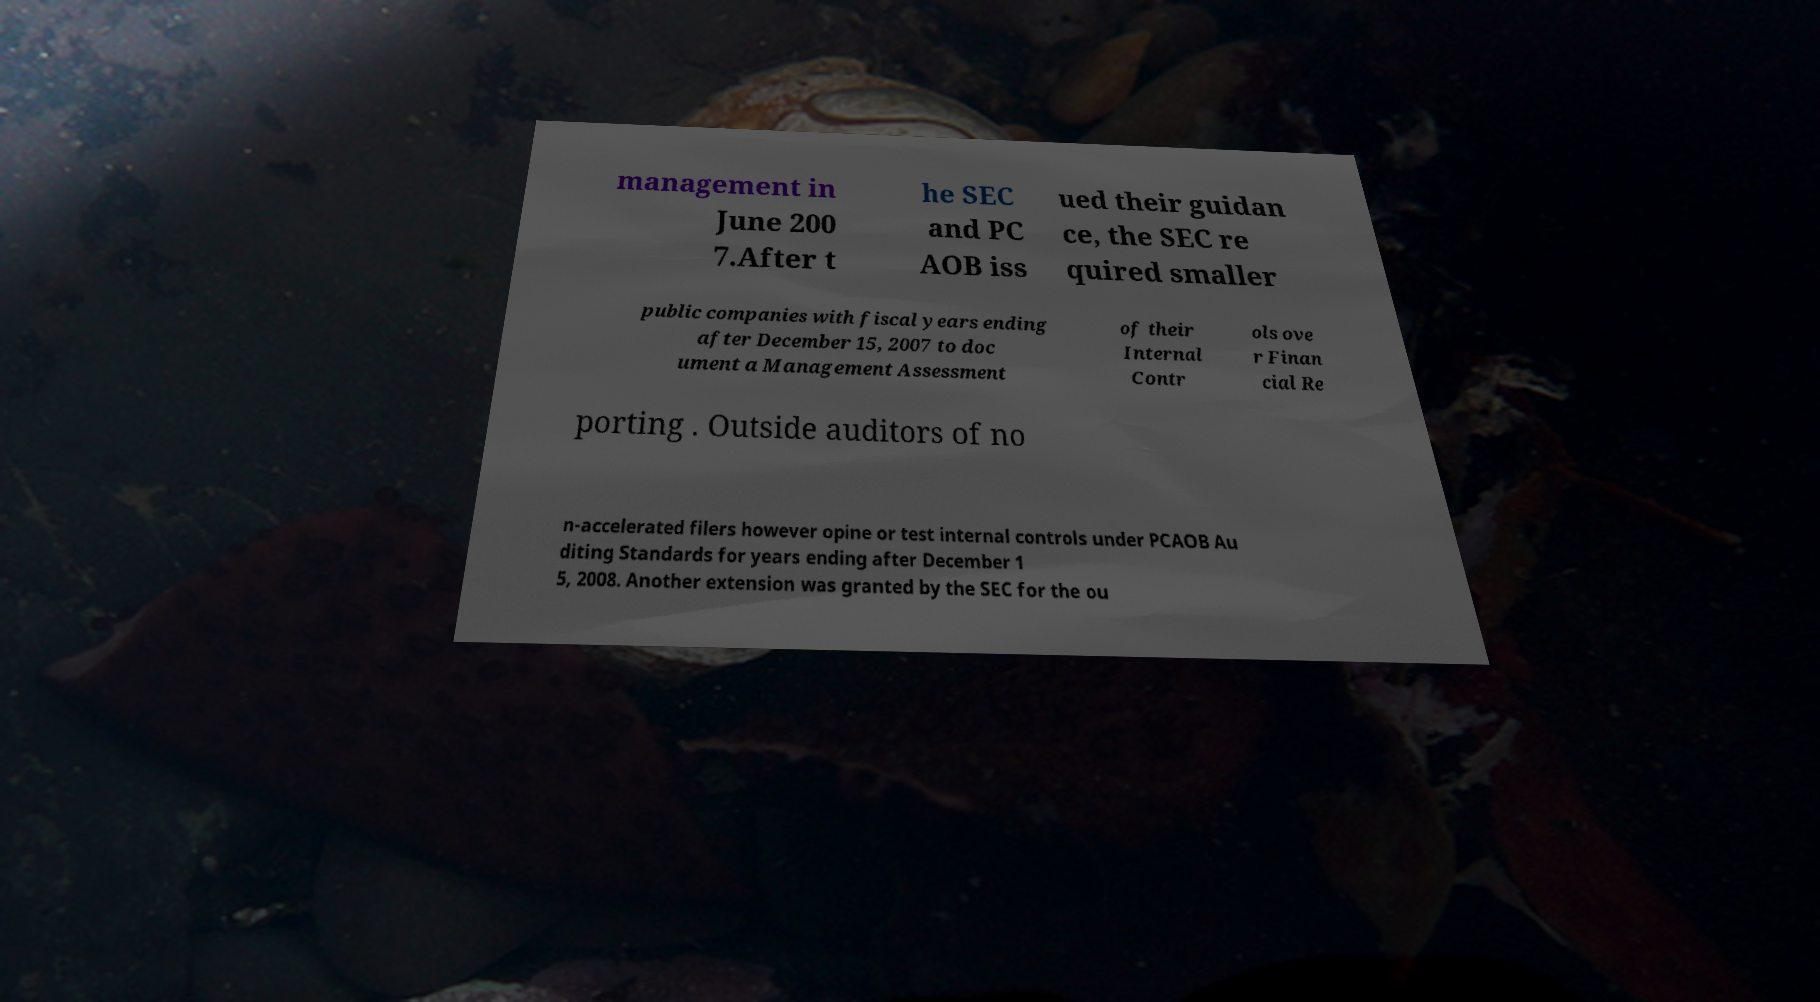Please read and relay the text visible in this image. What does it say? management in June 200 7.After t he SEC and PC AOB iss ued their guidan ce, the SEC re quired smaller public companies with fiscal years ending after December 15, 2007 to doc ument a Management Assessment of their Internal Contr ols ove r Finan cial Re porting . Outside auditors of no n-accelerated filers however opine or test internal controls under PCAOB Au diting Standards for years ending after December 1 5, 2008. Another extension was granted by the SEC for the ou 